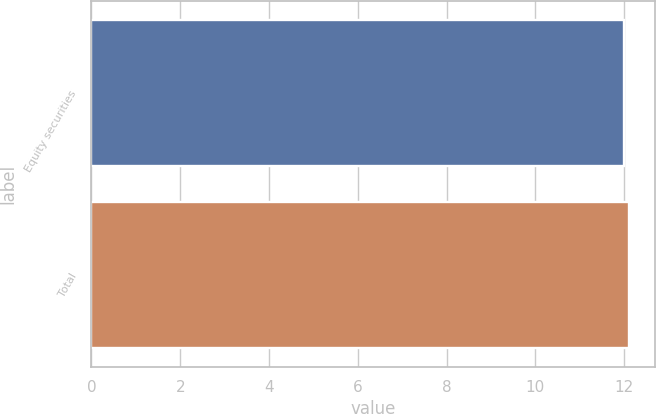Convert chart to OTSL. <chart><loc_0><loc_0><loc_500><loc_500><bar_chart><fcel>Equity securities<fcel>Total<nl><fcel>12<fcel>12.1<nl></chart> 